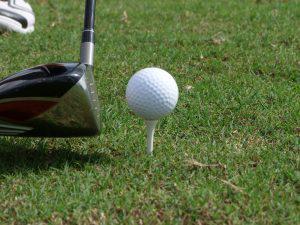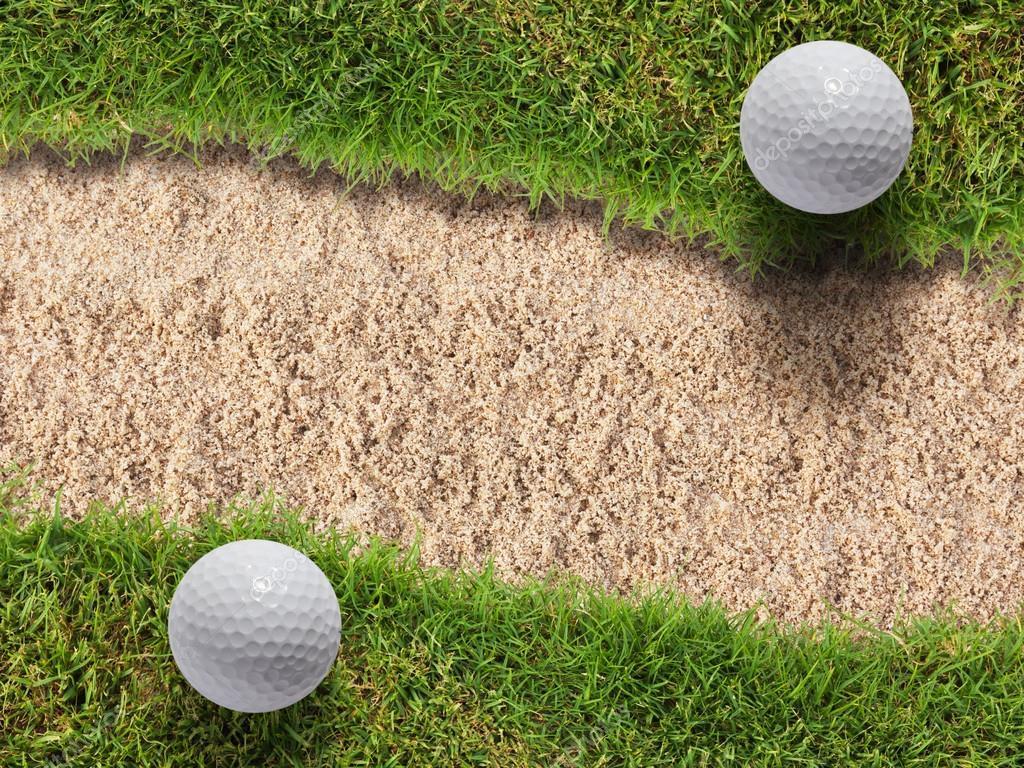The first image is the image on the left, the second image is the image on the right. For the images shown, is this caption "An image shows a golf club behind a ball that is not on a tee." true? Answer yes or no. No. 